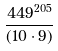<formula> <loc_0><loc_0><loc_500><loc_500>\frac { 4 4 9 ^ { 2 0 5 } } { ( 1 0 \cdot 9 ) }</formula> 